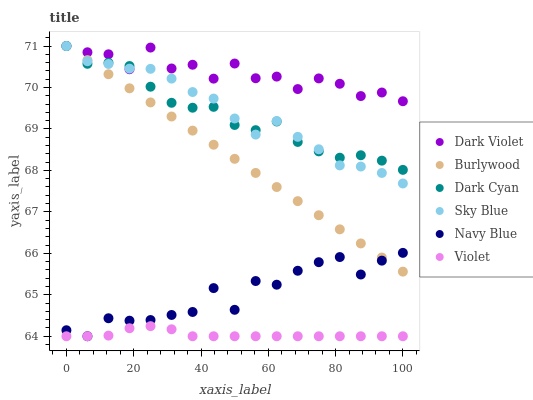Does Violet have the minimum area under the curve?
Answer yes or no. Yes. Does Dark Violet have the maximum area under the curve?
Answer yes or no. Yes. Does Navy Blue have the minimum area under the curve?
Answer yes or no. No. Does Navy Blue have the maximum area under the curve?
Answer yes or no. No. Is Burlywood the smoothest?
Answer yes or no. Yes. Is Dark Violet the roughest?
Answer yes or no. Yes. Is Navy Blue the smoothest?
Answer yes or no. No. Is Navy Blue the roughest?
Answer yes or no. No. Does Navy Blue have the lowest value?
Answer yes or no. Yes. Does Dark Violet have the lowest value?
Answer yes or no. No. Does Sky Blue have the highest value?
Answer yes or no. Yes. Does Navy Blue have the highest value?
Answer yes or no. No. Is Navy Blue less than Dark Cyan?
Answer yes or no. Yes. Is Dark Violet greater than Navy Blue?
Answer yes or no. Yes. Does Dark Violet intersect Burlywood?
Answer yes or no. Yes. Is Dark Violet less than Burlywood?
Answer yes or no. No. Is Dark Violet greater than Burlywood?
Answer yes or no. No. Does Navy Blue intersect Dark Cyan?
Answer yes or no. No. 